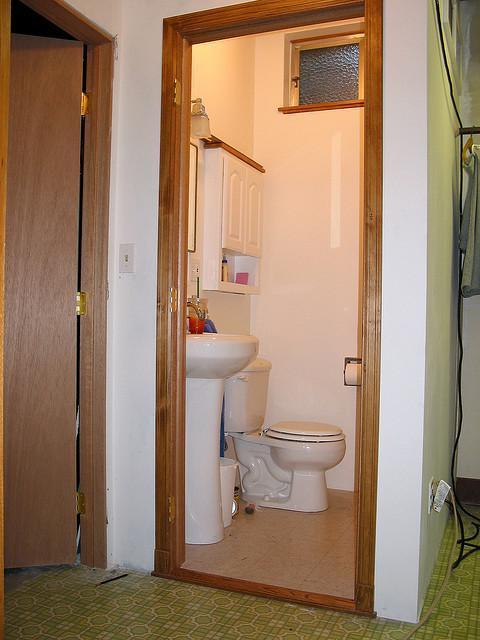How many people are wearing uniforms?
Give a very brief answer. 0. 